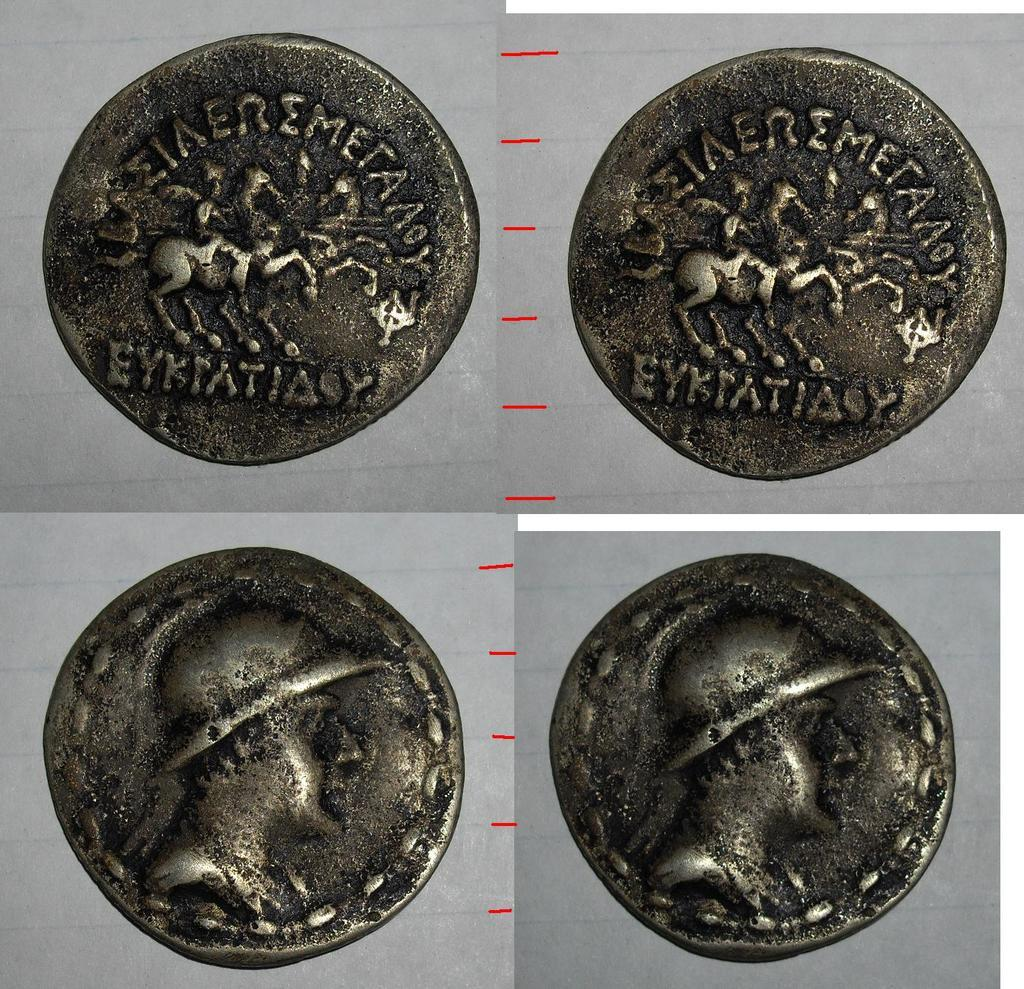What type of artwork is depicted in the image? The image is a collage. What objects can be seen in the collage? There are coins in the collage. What additional details can be observed on the coins? The coins have sculptures on them. Who is the owner of the oven in the image? There is no oven present in the image. How many buns are visible in the image? There are no buns present in the image. 